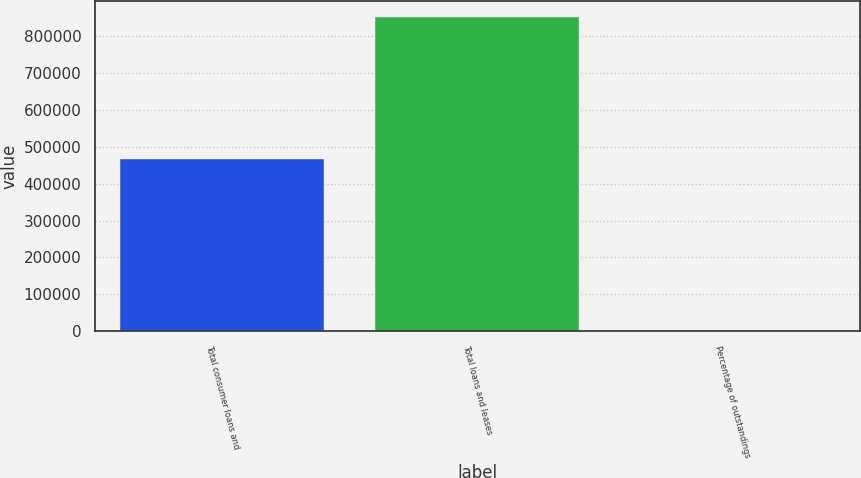Convert chart to OTSL. <chart><loc_0><loc_0><loc_500><loc_500><bar_chart><fcel>Total consumer loans and<fcel>Total loans and leases<fcel>Percentage of outstandings<nl><fcel>467117<fcel>853819<fcel>91.99<nl></chart> 